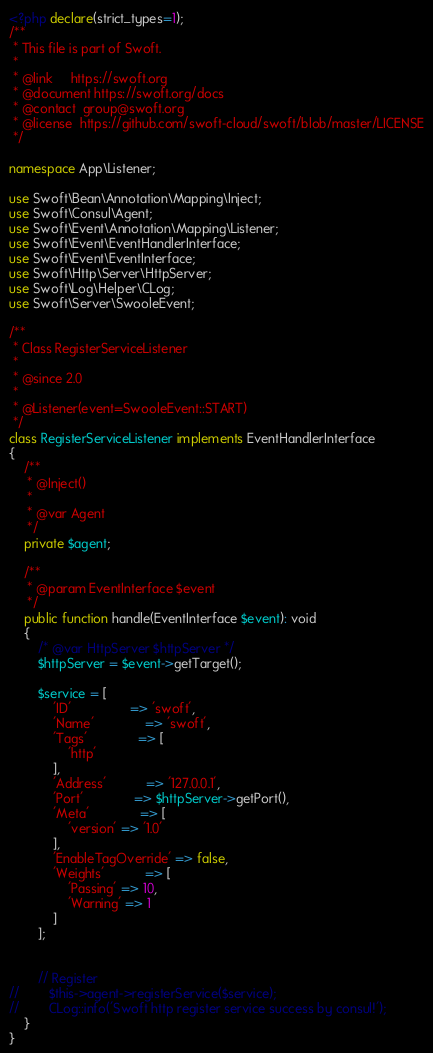<code> <loc_0><loc_0><loc_500><loc_500><_PHP_><?php declare(strict_types=1);
/**
 * This file is part of Swoft.
 *
 * @link     https://swoft.org
 * @document https://swoft.org/docs
 * @contact  group@swoft.org
 * @license  https://github.com/swoft-cloud/swoft/blob/master/LICENSE
 */

namespace App\Listener;

use Swoft\Bean\Annotation\Mapping\Inject;
use Swoft\Consul\Agent;
use Swoft\Event\Annotation\Mapping\Listener;
use Swoft\Event\EventHandlerInterface;
use Swoft\Event\EventInterface;
use Swoft\Http\Server\HttpServer;
use Swoft\Log\Helper\CLog;
use Swoft\Server\SwooleEvent;

/**
 * Class RegisterServiceListener
 *
 * @since 2.0
 *
 * @Listener(event=SwooleEvent::START)
 */
class RegisterServiceListener implements EventHandlerInterface
{
    /**
     * @Inject()
     *
     * @var Agent
     */
    private $agent;

    /**
     * @param EventInterface $event
     */
    public function handle(EventInterface $event): void
    {
        /* @var HttpServer $httpServer */
        $httpServer = $event->getTarget();

        $service = [
            'ID'                => 'swoft',
            'Name'              => 'swoft',
            'Tags'              => [
                'http'
            ],
            'Address'           => '127.0.0.1',
            'Port'              => $httpServer->getPort(),
            'Meta'              => [
                'version' => '1.0'
            ],
            'EnableTagOverride' => false,
            'Weights'           => [
                'Passing' => 10,
                'Warning' => 1
            ]
        ];


        // Register
//        $this->agent->registerService($service);
//        CLog::info('Swoft http register service success by consul!');
    }
}
</code> 